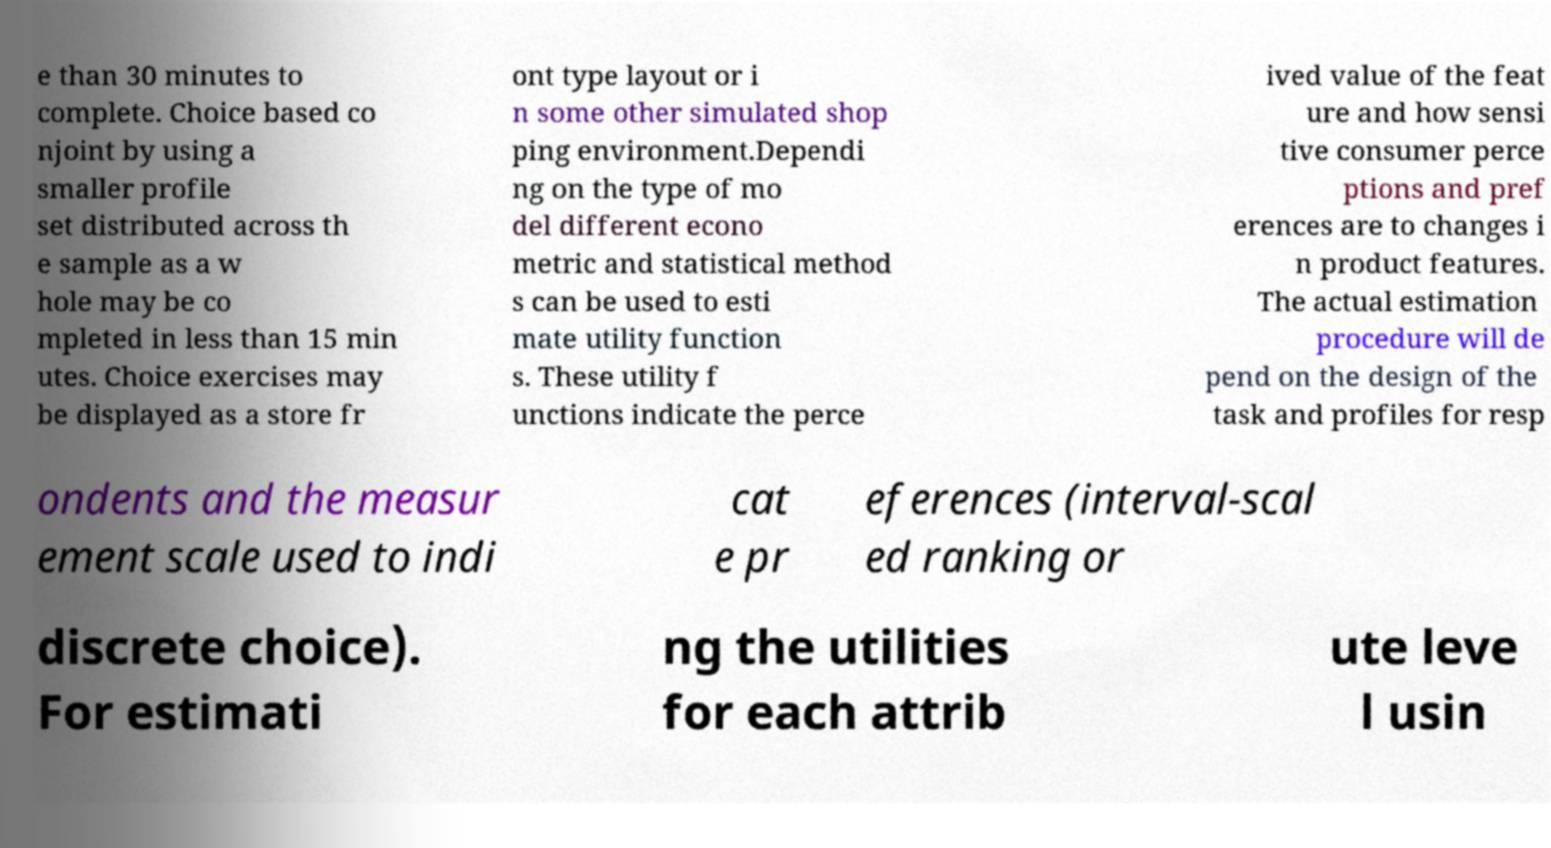Could you extract and type out the text from this image? e than 30 minutes to complete. Choice based co njoint by using a smaller profile set distributed across th e sample as a w hole may be co mpleted in less than 15 min utes. Choice exercises may be displayed as a store fr ont type layout or i n some other simulated shop ping environment.Dependi ng on the type of mo del different econo metric and statistical method s can be used to esti mate utility function s. These utility f unctions indicate the perce ived value of the feat ure and how sensi tive consumer perce ptions and pref erences are to changes i n product features. The actual estimation procedure will de pend on the design of the task and profiles for resp ondents and the measur ement scale used to indi cat e pr eferences (interval-scal ed ranking or discrete choice). For estimati ng the utilities for each attrib ute leve l usin 